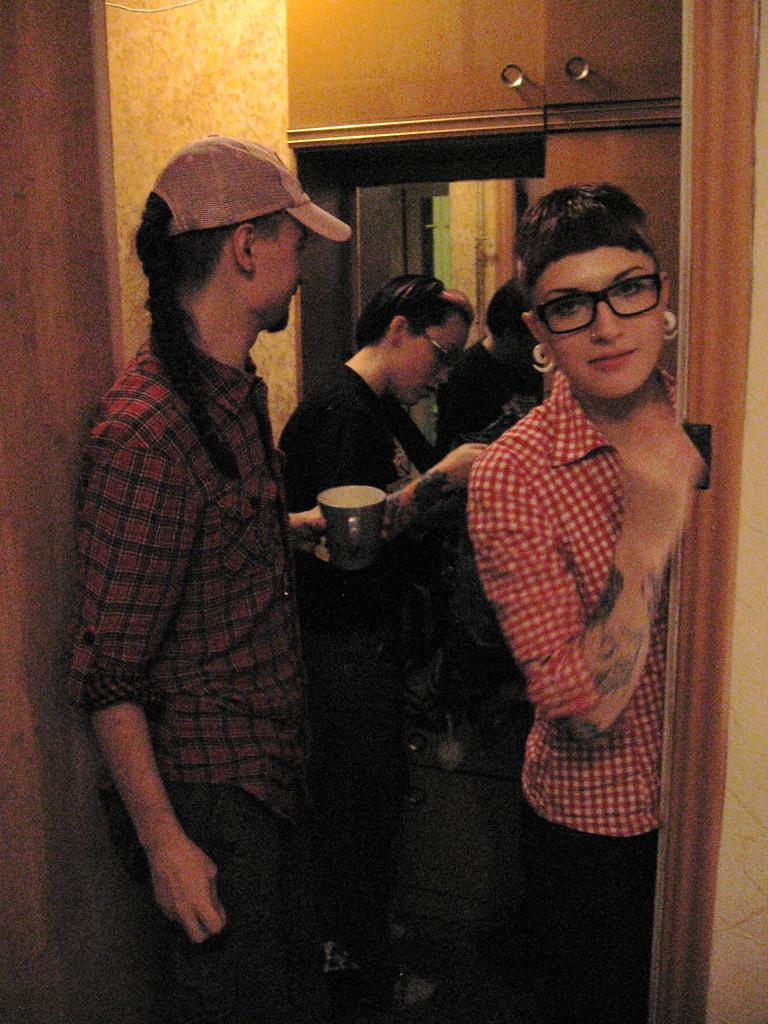How many people are in the image? There are three people in the image. Can you describe the appearance of one of the women? One of the women is wearing spectacles and smiling. What is one person wearing in the image? One person is wearing a cap. What is the person holding in the image? The person is holding a cup. What can be seen in the background of the image? There is a mirror and a wall in the image. Are there any other objects visible in the image? Yes, there are other objects in the image. What type of dirt can be seen on the spade in the image? There is no spade or dirt present in the image. How old is the baby in the image? There is no baby present in the image. 